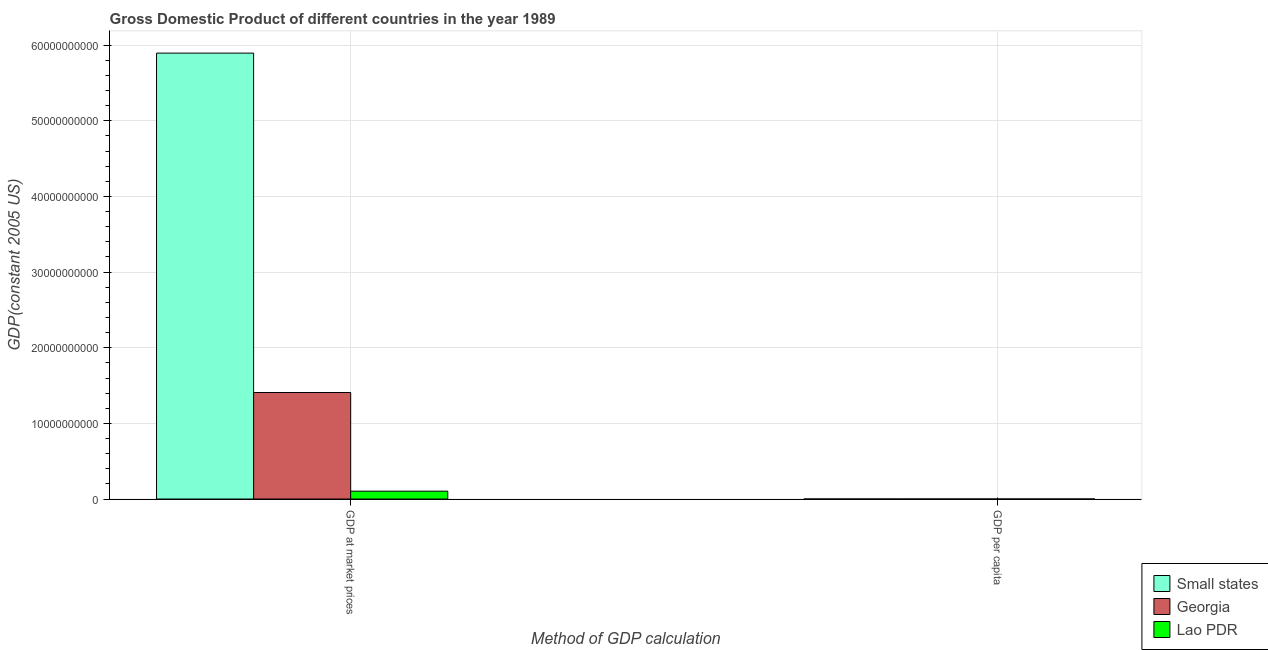How many groups of bars are there?
Offer a terse response. 2. Are the number of bars per tick equal to the number of legend labels?
Make the answer very short. Yes. How many bars are there on the 1st tick from the right?
Give a very brief answer. 3. What is the label of the 2nd group of bars from the left?
Make the answer very short. GDP per capita. What is the gdp per capita in Georgia?
Offer a very short reply. 2931.92. Across all countries, what is the maximum gdp at market prices?
Your response must be concise. 5.90e+1. Across all countries, what is the minimum gdp per capita?
Make the answer very short. 252.09. In which country was the gdp per capita maximum?
Provide a succinct answer. Georgia. In which country was the gdp per capita minimum?
Your answer should be compact. Lao PDR. What is the total gdp at market prices in the graph?
Your answer should be compact. 7.41e+1. What is the difference between the gdp per capita in Small states and that in Lao PDR?
Keep it short and to the point. 2624.28. What is the difference between the gdp at market prices in Georgia and the gdp per capita in Small states?
Offer a very short reply. 1.41e+1. What is the average gdp at market prices per country?
Your response must be concise. 2.47e+1. What is the difference between the gdp at market prices and gdp per capita in Georgia?
Offer a very short reply. 1.41e+1. In how many countries, is the gdp at market prices greater than 38000000000 US$?
Give a very brief answer. 1. What is the ratio of the gdp at market prices in Lao PDR to that in Georgia?
Your answer should be very brief. 0.07. In how many countries, is the gdp at market prices greater than the average gdp at market prices taken over all countries?
Ensure brevity in your answer.  1. What does the 3rd bar from the left in GDP per capita represents?
Provide a short and direct response. Lao PDR. What does the 2nd bar from the right in GDP per capita represents?
Your answer should be compact. Georgia. How many bars are there?
Keep it short and to the point. 6. Are all the bars in the graph horizontal?
Offer a terse response. No. How many countries are there in the graph?
Offer a very short reply. 3. What is the difference between two consecutive major ticks on the Y-axis?
Your answer should be compact. 1.00e+1. Does the graph contain any zero values?
Give a very brief answer. No. Does the graph contain grids?
Your response must be concise. Yes. What is the title of the graph?
Provide a short and direct response. Gross Domestic Product of different countries in the year 1989. What is the label or title of the X-axis?
Your answer should be very brief. Method of GDP calculation. What is the label or title of the Y-axis?
Provide a short and direct response. GDP(constant 2005 US). What is the GDP(constant 2005 US) in Small states in GDP at market prices?
Offer a terse response. 5.90e+1. What is the GDP(constant 2005 US) of Georgia in GDP at market prices?
Ensure brevity in your answer.  1.41e+1. What is the GDP(constant 2005 US) of Lao PDR in GDP at market prices?
Give a very brief answer. 1.04e+09. What is the GDP(constant 2005 US) in Small states in GDP per capita?
Offer a very short reply. 2876.37. What is the GDP(constant 2005 US) of Georgia in GDP per capita?
Provide a short and direct response. 2931.92. What is the GDP(constant 2005 US) in Lao PDR in GDP per capita?
Offer a terse response. 252.09. Across all Method of GDP calculation, what is the maximum GDP(constant 2005 US) of Small states?
Offer a terse response. 5.90e+1. Across all Method of GDP calculation, what is the maximum GDP(constant 2005 US) of Georgia?
Ensure brevity in your answer.  1.41e+1. Across all Method of GDP calculation, what is the maximum GDP(constant 2005 US) of Lao PDR?
Provide a short and direct response. 1.04e+09. Across all Method of GDP calculation, what is the minimum GDP(constant 2005 US) of Small states?
Your answer should be very brief. 2876.37. Across all Method of GDP calculation, what is the minimum GDP(constant 2005 US) of Georgia?
Your response must be concise. 2931.92. Across all Method of GDP calculation, what is the minimum GDP(constant 2005 US) of Lao PDR?
Ensure brevity in your answer.  252.09. What is the total GDP(constant 2005 US) in Small states in the graph?
Offer a terse response. 5.90e+1. What is the total GDP(constant 2005 US) in Georgia in the graph?
Provide a succinct answer. 1.41e+1. What is the total GDP(constant 2005 US) in Lao PDR in the graph?
Ensure brevity in your answer.  1.04e+09. What is the difference between the GDP(constant 2005 US) in Small states in GDP at market prices and that in GDP per capita?
Give a very brief answer. 5.90e+1. What is the difference between the GDP(constant 2005 US) of Georgia in GDP at market prices and that in GDP per capita?
Your answer should be compact. 1.41e+1. What is the difference between the GDP(constant 2005 US) of Lao PDR in GDP at market prices and that in GDP per capita?
Provide a succinct answer. 1.04e+09. What is the difference between the GDP(constant 2005 US) of Small states in GDP at market prices and the GDP(constant 2005 US) of Georgia in GDP per capita?
Keep it short and to the point. 5.90e+1. What is the difference between the GDP(constant 2005 US) in Small states in GDP at market prices and the GDP(constant 2005 US) in Lao PDR in GDP per capita?
Offer a terse response. 5.90e+1. What is the difference between the GDP(constant 2005 US) in Georgia in GDP at market prices and the GDP(constant 2005 US) in Lao PDR in GDP per capita?
Your answer should be compact. 1.41e+1. What is the average GDP(constant 2005 US) in Small states per Method of GDP calculation?
Give a very brief answer. 2.95e+1. What is the average GDP(constant 2005 US) in Georgia per Method of GDP calculation?
Provide a short and direct response. 7.04e+09. What is the average GDP(constant 2005 US) in Lao PDR per Method of GDP calculation?
Your answer should be very brief. 5.20e+08. What is the difference between the GDP(constant 2005 US) of Small states and GDP(constant 2005 US) of Georgia in GDP at market prices?
Offer a terse response. 4.49e+1. What is the difference between the GDP(constant 2005 US) of Small states and GDP(constant 2005 US) of Lao PDR in GDP at market prices?
Ensure brevity in your answer.  5.79e+1. What is the difference between the GDP(constant 2005 US) in Georgia and GDP(constant 2005 US) in Lao PDR in GDP at market prices?
Keep it short and to the point. 1.30e+1. What is the difference between the GDP(constant 2005 US) in Small states and GDP(constant 2005 US) in Georgia in GDP per capita?
Make the answer very short. -55.55. What is the difference between the GDP(constant 2005 US) in Small states and GDP(constant 2005 US) in Lao PDR in GDP per capita?
Your response must be concise. 2624.28. What is the difference between the GDP(constant 2005 US) of Georgia and GDP(constant 2005 US) of Lao PDR in GDP per capita?
Ensure brevity in your answer.  2679.83. What is the ratio of the GDP(constant 2005 US) in Small states in GDP at market prices to that in GDP per capita?
Make the answer very short. 2.05e+07. What is the ratio of the GDP(constant 2005 US) of Georgia in GDP at market prices to that in GDP per capita?
Provide a short and direct response. 4.80e+06. What is the ratio of the GDP(constant 2005 US) of Lao PDR in GDP at market prices to that in GDP per capita?
Offer a very short reply. 4.13e+06. What is the difference between the highest and the second highest GDP(constant 2005 US) of Small states?
Provide a short and direct response. 5.90e+1. What is the difference between the highest and the second highest GDP(constant 2005 US) in Georgia?
Provide a succinct answer. 1.41e+1. What is the difference between the highest and the second highest GDP(constant 2005 US) in Lao PDR?
Ensure brevity in your answer.  1.04e+09. What is the difference between the highest and the lowest GDP(constant 2005 US) of Small states?
Ensure brevity in your answer.  5.90e+1. What is the difference between the highest and the lowest GDP(constant 2005 US) of Georgia?
Your answer should be compact. 1.41e+1. What is the difference between the highest and the lowest GDP(constant 2005 US) in Lao PDR?
Give a very brief answer. 1.04e+09. 